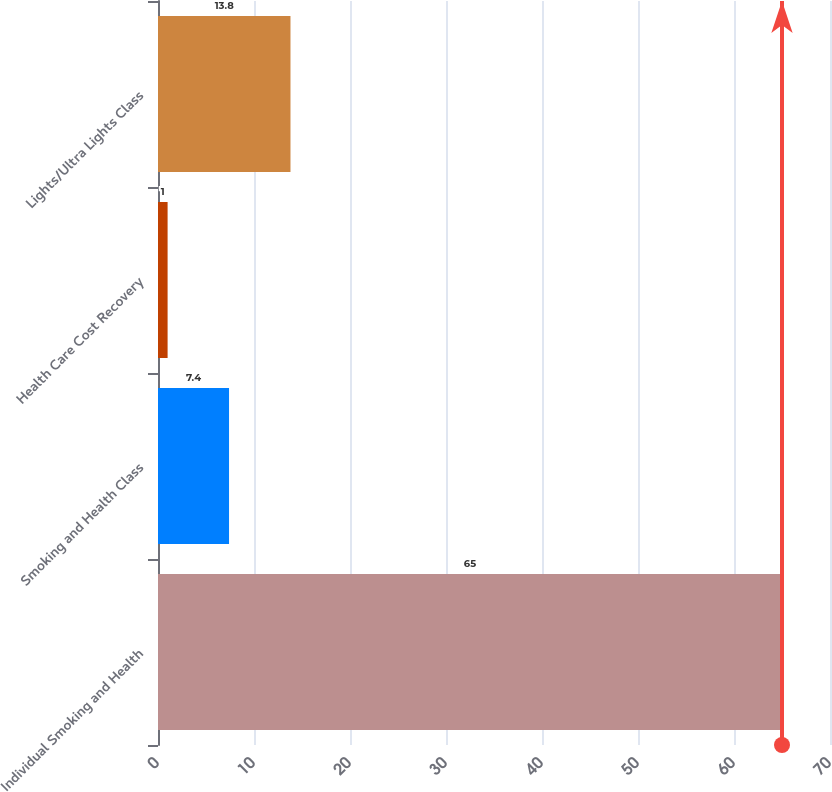Convert chart. <chart><loc_0><loc_0><loc_500><loc_500><bar_chart><fcel>Individual Smoking and Health<fcel>Smoking and Health Class<fcel>Health Care Cost Recovery<fcel>Lights/Ultra Lights Class<nl><fcel>65<fcel>7.4<fcel>1<fcel>13.8<nl></chart> 